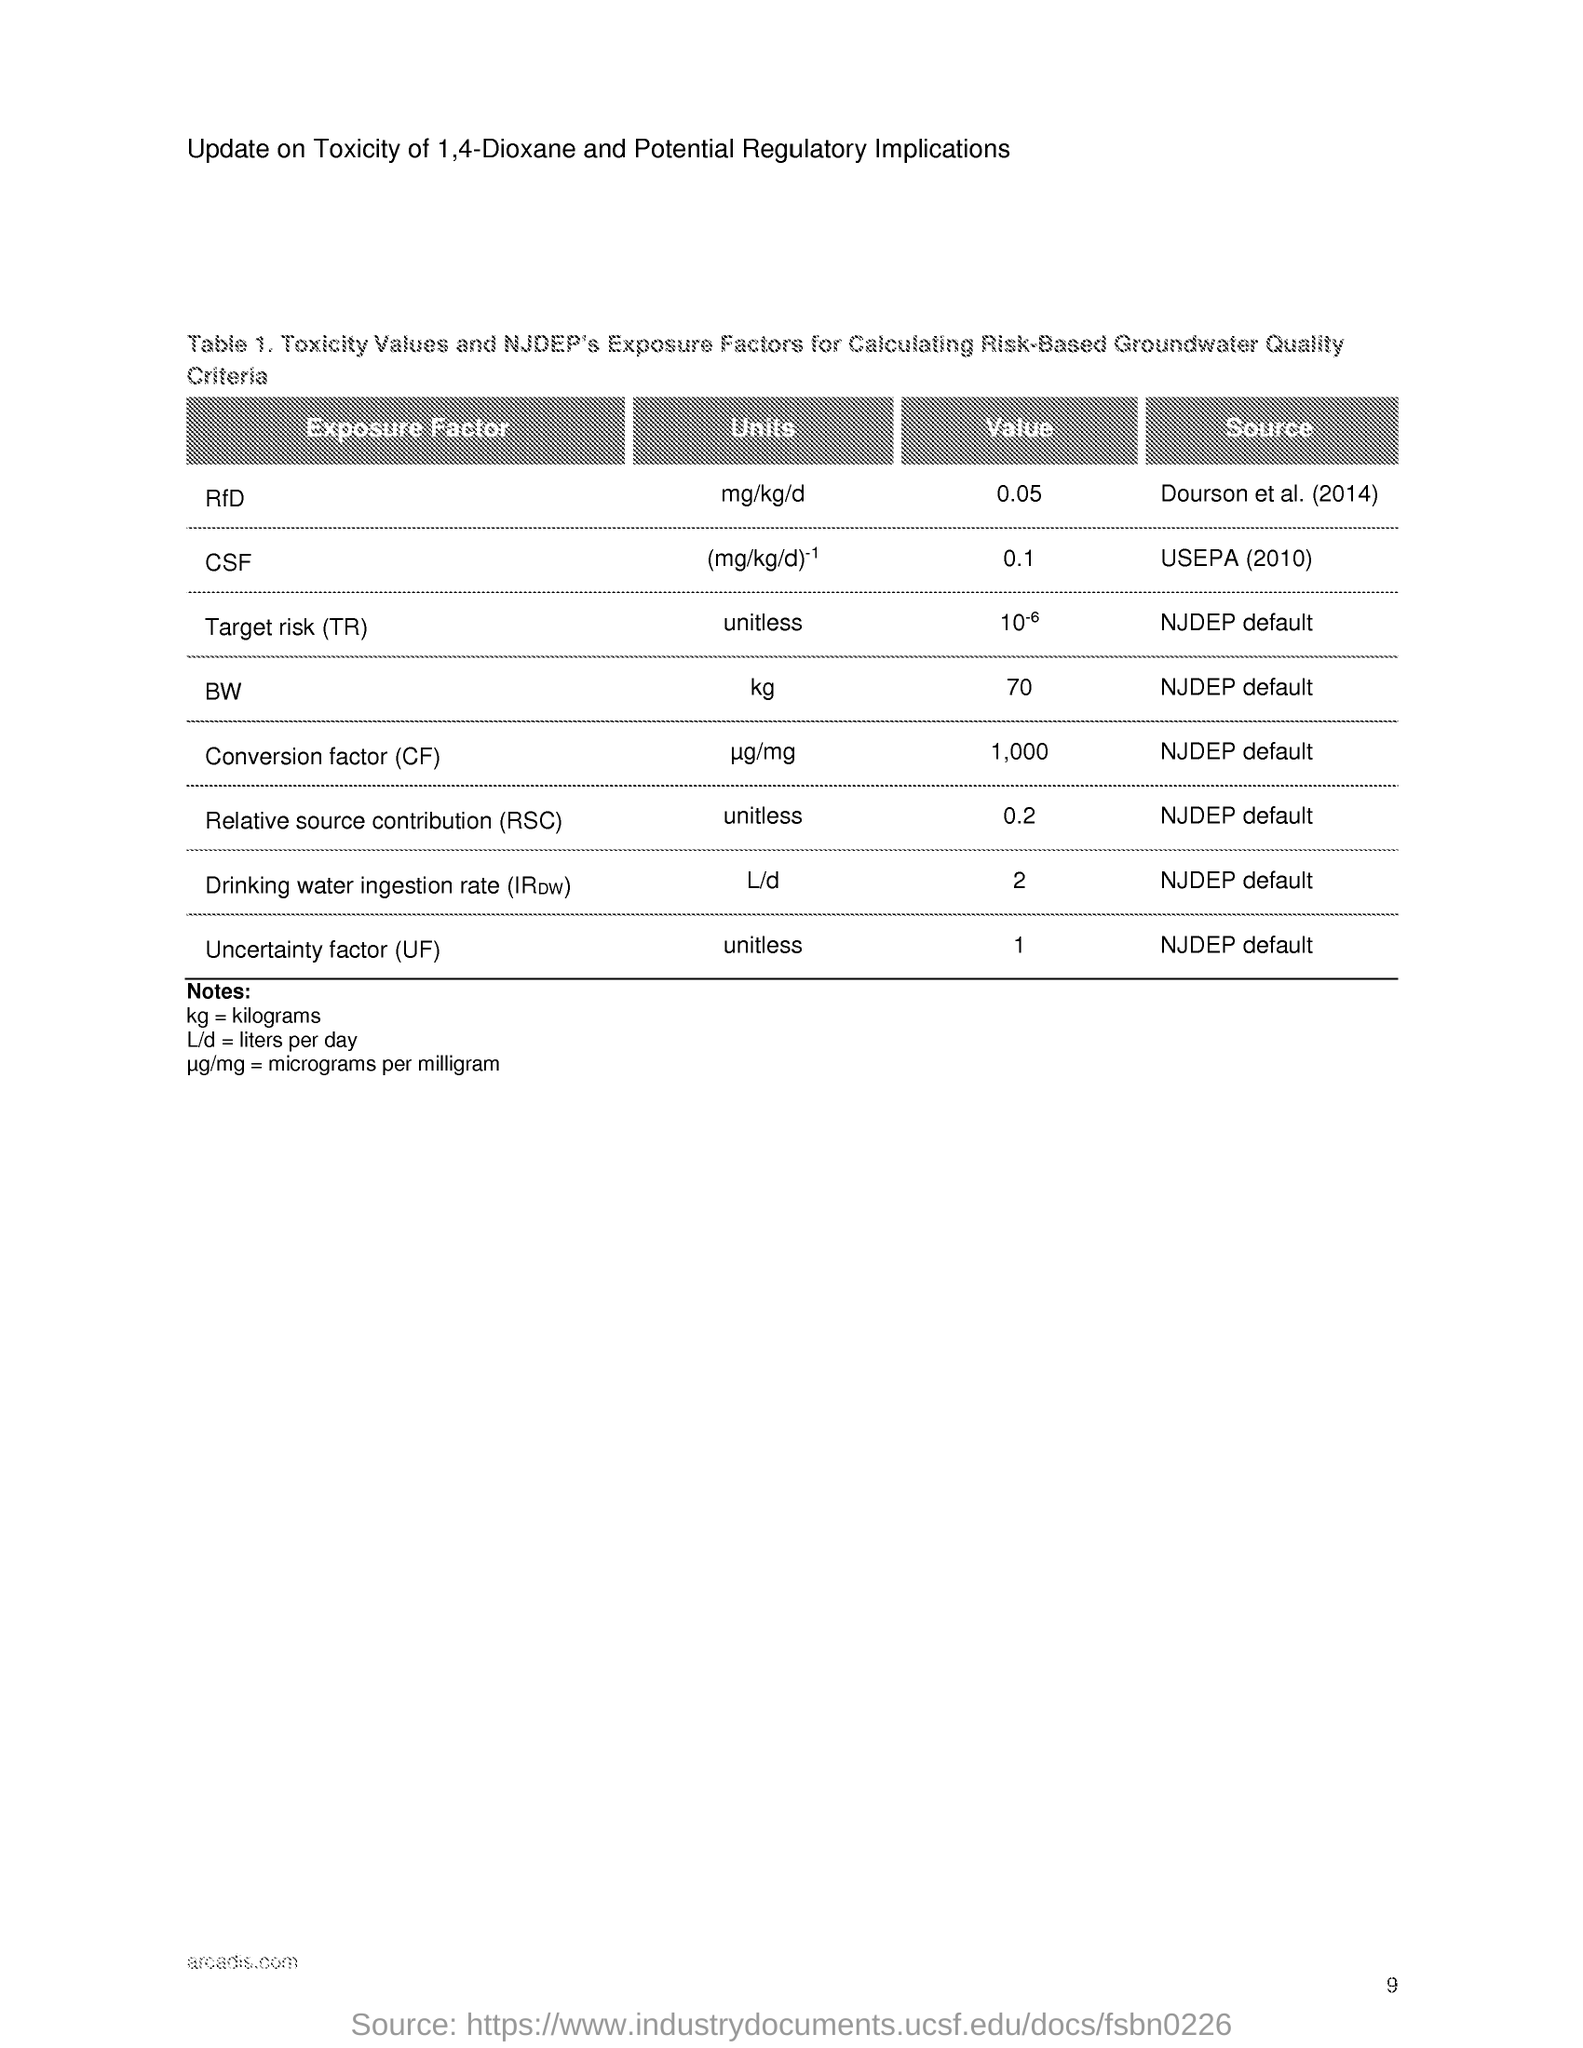What are the units of bw ?
Keep it short and to the point. Kg. What is the value csf ?
Give a very brief answer. 0.1. What is kg mentioned as ?
Offer a very short reply. Kilograms. What is l/d mentioned as ?
Provide a short and direct response. Liters per day. What is the value of conversion factor ?
Keep it short and to the point. 1,000. What is rsc stands for ?
Ensure brevity in your answer.  Relative source contribution. What is tr stands for ?
Ensure brevity in your answer.  Target risk. What is the unit of uncertainty factor ?
Provide a succinct answer. Unitless. 